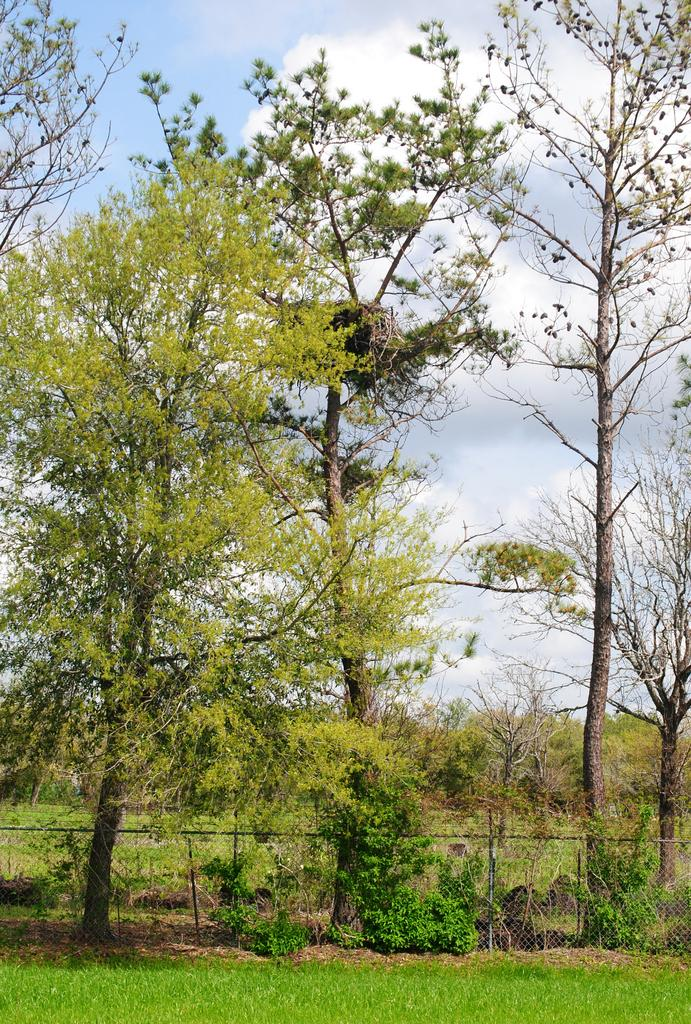What type of vegetation can be seen in the image? There are trees and plants in the image. What is the texture of the mesh in the image? The mesh in the image has a net-like texture. What type of ground cover is present in the image? There is grass in the image. What can be seen in the background of the image? There are trees and a cloudy sky in the background of the image. How much payment is required to enter the tree in the image? There is no tree in the image that requires payment to enter, as the image only features trees and plants in a natural setting. 